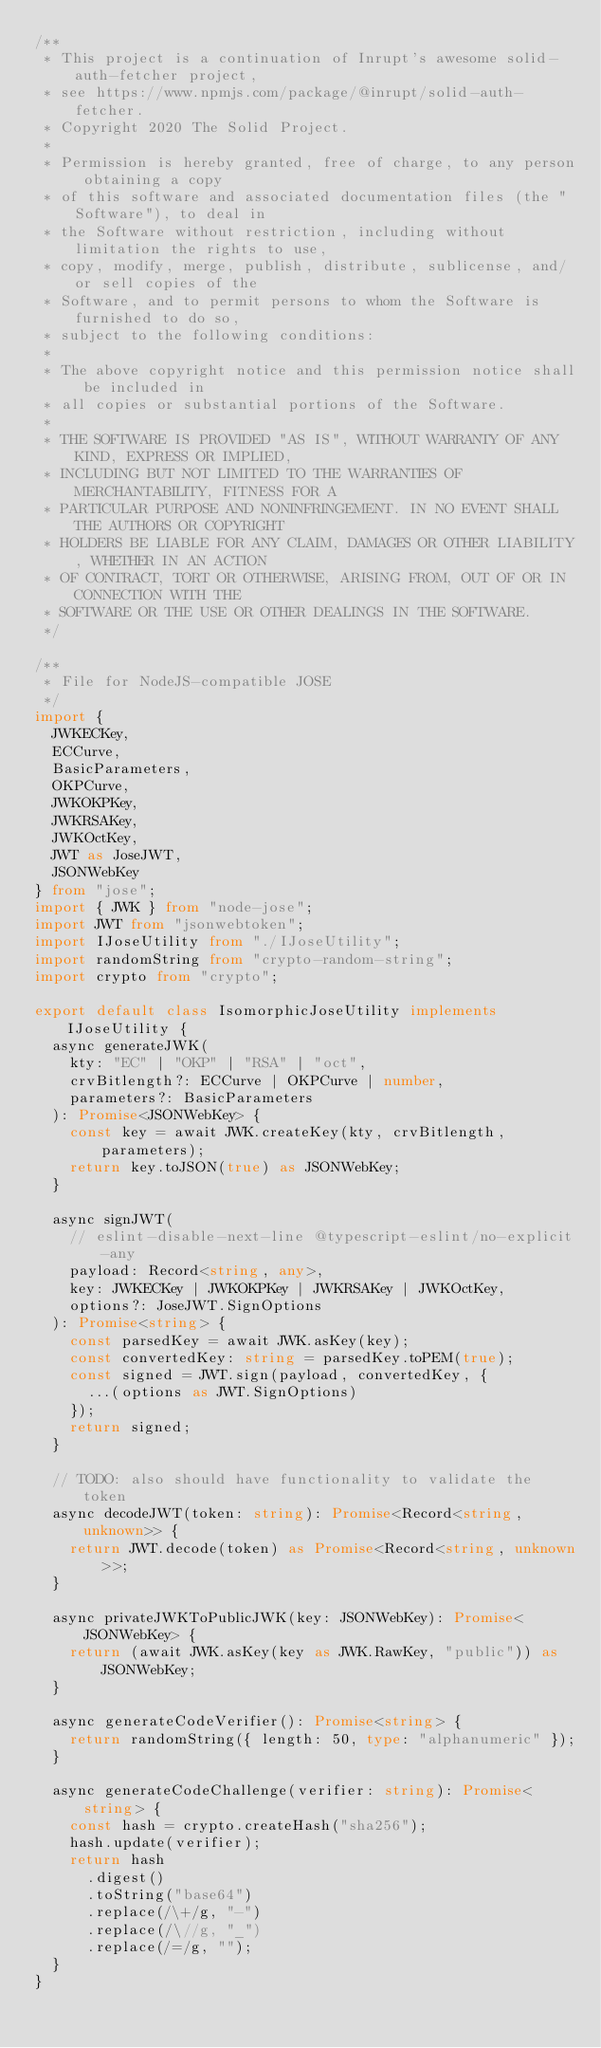Convert code to text. <code><loc_0><loc_0><loc_500><loc_500><_TypeScript_>/**
 * This project is a continuation of Inrupt's awesome solid-auth-fetcher project,
 * see https://www.npmjs.com/package/@inrupt/solid-auth-fetcher.
 * Copyright 2020 The Solid Project.
 *
 * Permission is hereby granted, free of charge, to any person obtaining a copy
 * of this software and associated documentation files (the "Software"), to deal in
 * the Software without restriction, including without limitation the rights to use,
 * copy, modify, merge, publish, distribute, sublicense, and/or sell copies of the
 * Software, and to permit persons to whom the Software is furnished to do so,
 * subject to the following conditions:
 *
 * The above copyright notice and this permission notice shall be included in
 * all copies or substantial portions of the Software.
 *
 * THE SOFTWARE IS PROVIDED "AS IS", WITHOUT WARRANTY OF ANY KIND, EXPRESS OR IMPLIED,
 * INCLUDING BUT NOT LIMITED TO THE WARRANTIES OF MERCHANTABILITY, FITNESS FOR A
 * PARTICULAR PURPOSE AND NONINFRINGEMENT. IN NO EVENT SHALL THE AUTHORS OR COPYRIGHT
 * HOLDERS BE LIABLE FOR ANY CLAIM, DAMAGES OR OTHER LIABILITY, WHETHER IN AN ACTION
 * OF CONTRACT, TORT OR OTHERWISE, ARISING FROM, OUT OF OR IN CONNECTION WITH THE
 * SOFTWARE OR THE USE OR OTHER DEALINGS IN THE SOFTWARE.
 */

/**
 * File for NodeJS-compatible JOSE
 */
import {
  JWKECKey,
  ECCurve,
  BasicParameters,
  OKPCurve,
  JWKOKPKey,
  JWKRSAKey,
  JWKOctKey,
  JWT as JoseJWT,
  JSONWebKey
} from "jose";
import { JWK } from "node-jose";
import JWT from "jsonwebtoken";
import IJoseUtility from "./IJoseUtility";
import randomString from "crypto-random-string";
import crypto from "crypto";

export default class IsomorphicJoseUtility implements IJoseUtility {
  async generateJWK(
    kty: "EC" | "OKP" | "RSA" | "oct",
    crvBitlength?: ECCurve | OKPCurve | number,
    parameters?: BasicParameters
  ): Promise<JSONWebKey> {
    const key = await JWK.createKey(kty, crvBitlength, parameters);
    return key.toJSON(true) as JSONWebKey;
  }

  async signJWT(
    // eslint-disable-next-line @typescript-eslint/no-explicit-any
    payload: Record<string, any>,
    key: JWKECKey | JWKOKPKey | JWKRSAKey | JWKOctKey,
    options?: JoseJWT.SignOptions
  ): Promise<string> {
    const parsedKey = await JWK.asKey(key);
    const convertedKey: string = parsedKey.toPEM(true);
    const signed = JWT.sign(payload, convertedKey, {
      ...(options as JWT.SignOptions)
    });
    return signed;
  }

  // TODO: also should have functionality to validate the token
  async decodeJWT(token: string): Promise<Record<string, unknown>> {
    return JWT.decode(token) as Promise<Record<string, unknown>>;
  }

  async privateJWKToPublicJWK(key: JSONWebKey): Promise<JSONWebKey> {
    return (await JWK.asKey(key as JWK.RawKey, "public")) as JSONWebKey;
  }

  async generateCodeVerifier(): Promise<string> {
    return randomString({ length: 50, type: "alphanumeric" });
  }

  async generateCodeChallenge(verifier: string): Promise<string> {
    const hash = crypto.createHash("sha256");
    hash.update(verifier);
    return hash
      .digest()
      .toString("base64")
      .replace(/\+/g, "-")
      .replace(/\//g, "_")
      .replace(/=/g, "");
  }
}
</code> 